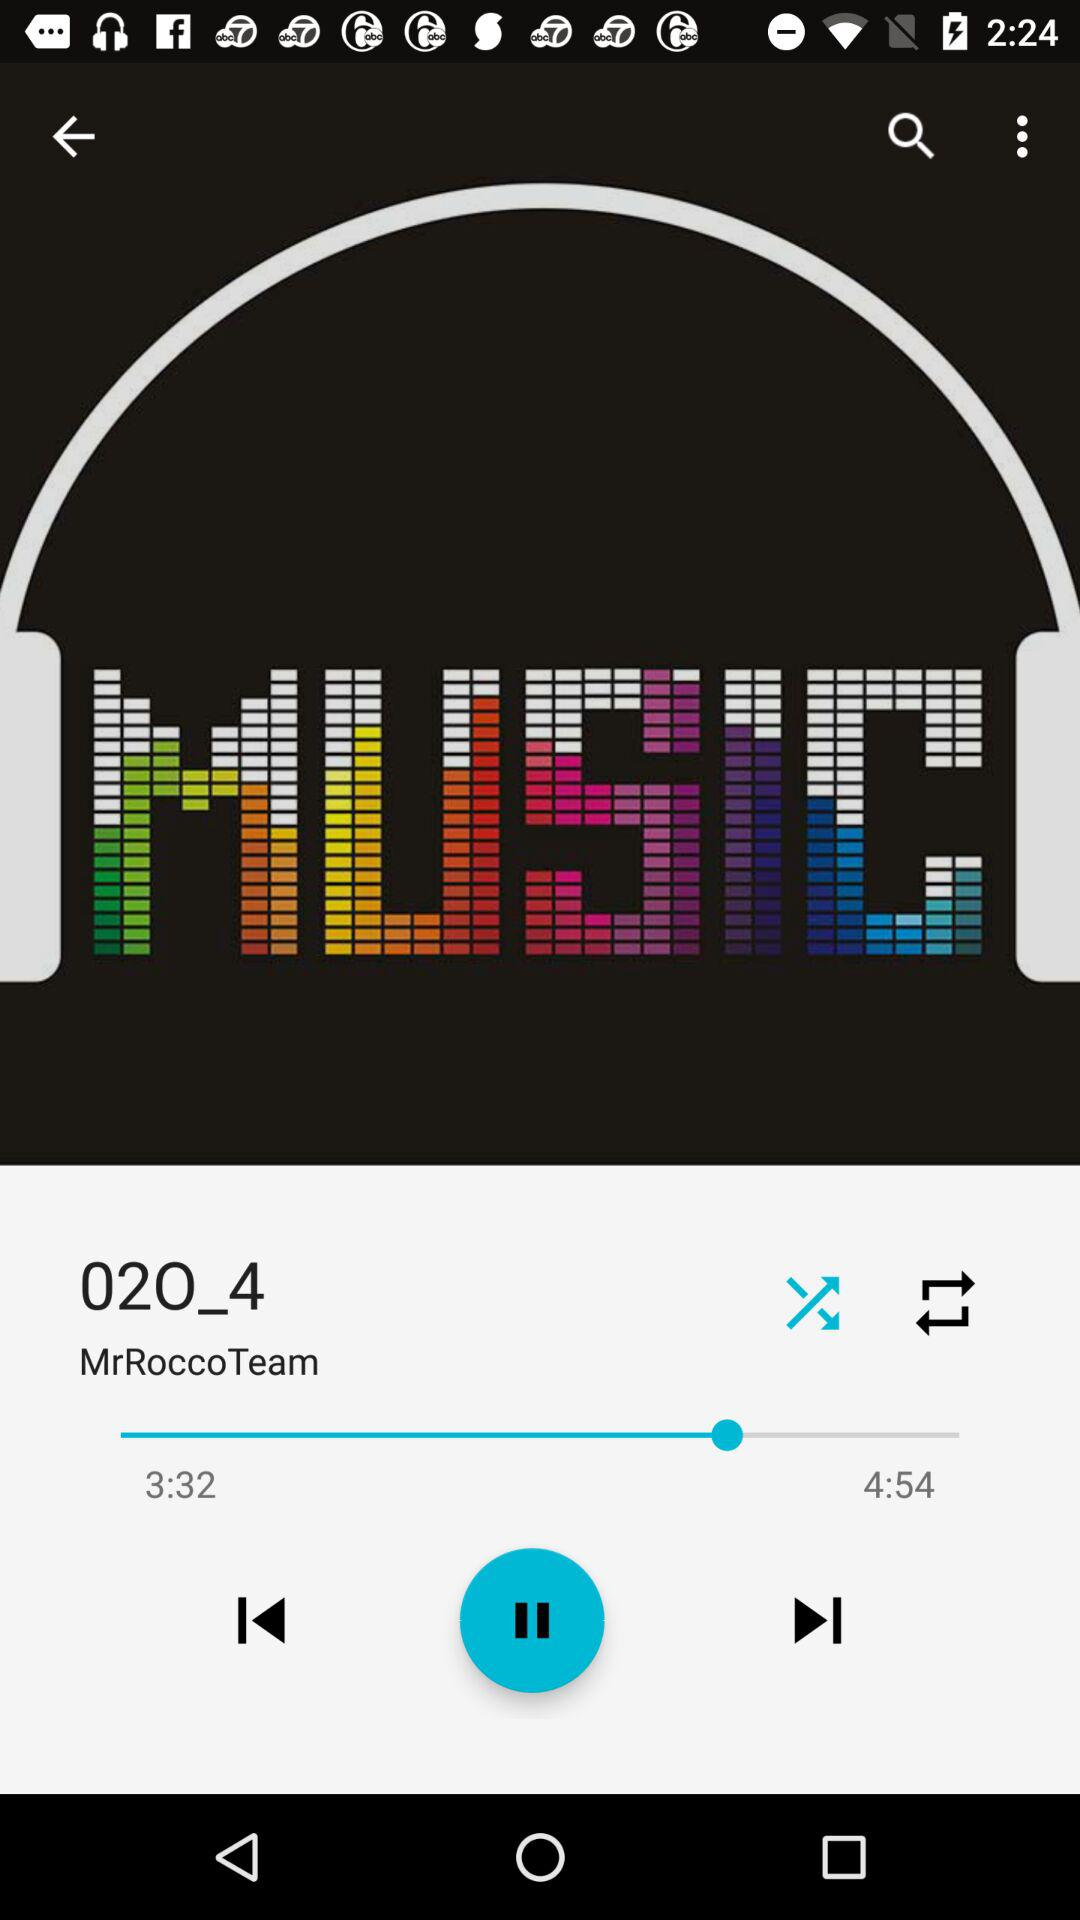What is the song name? The song name is "02O_4". 